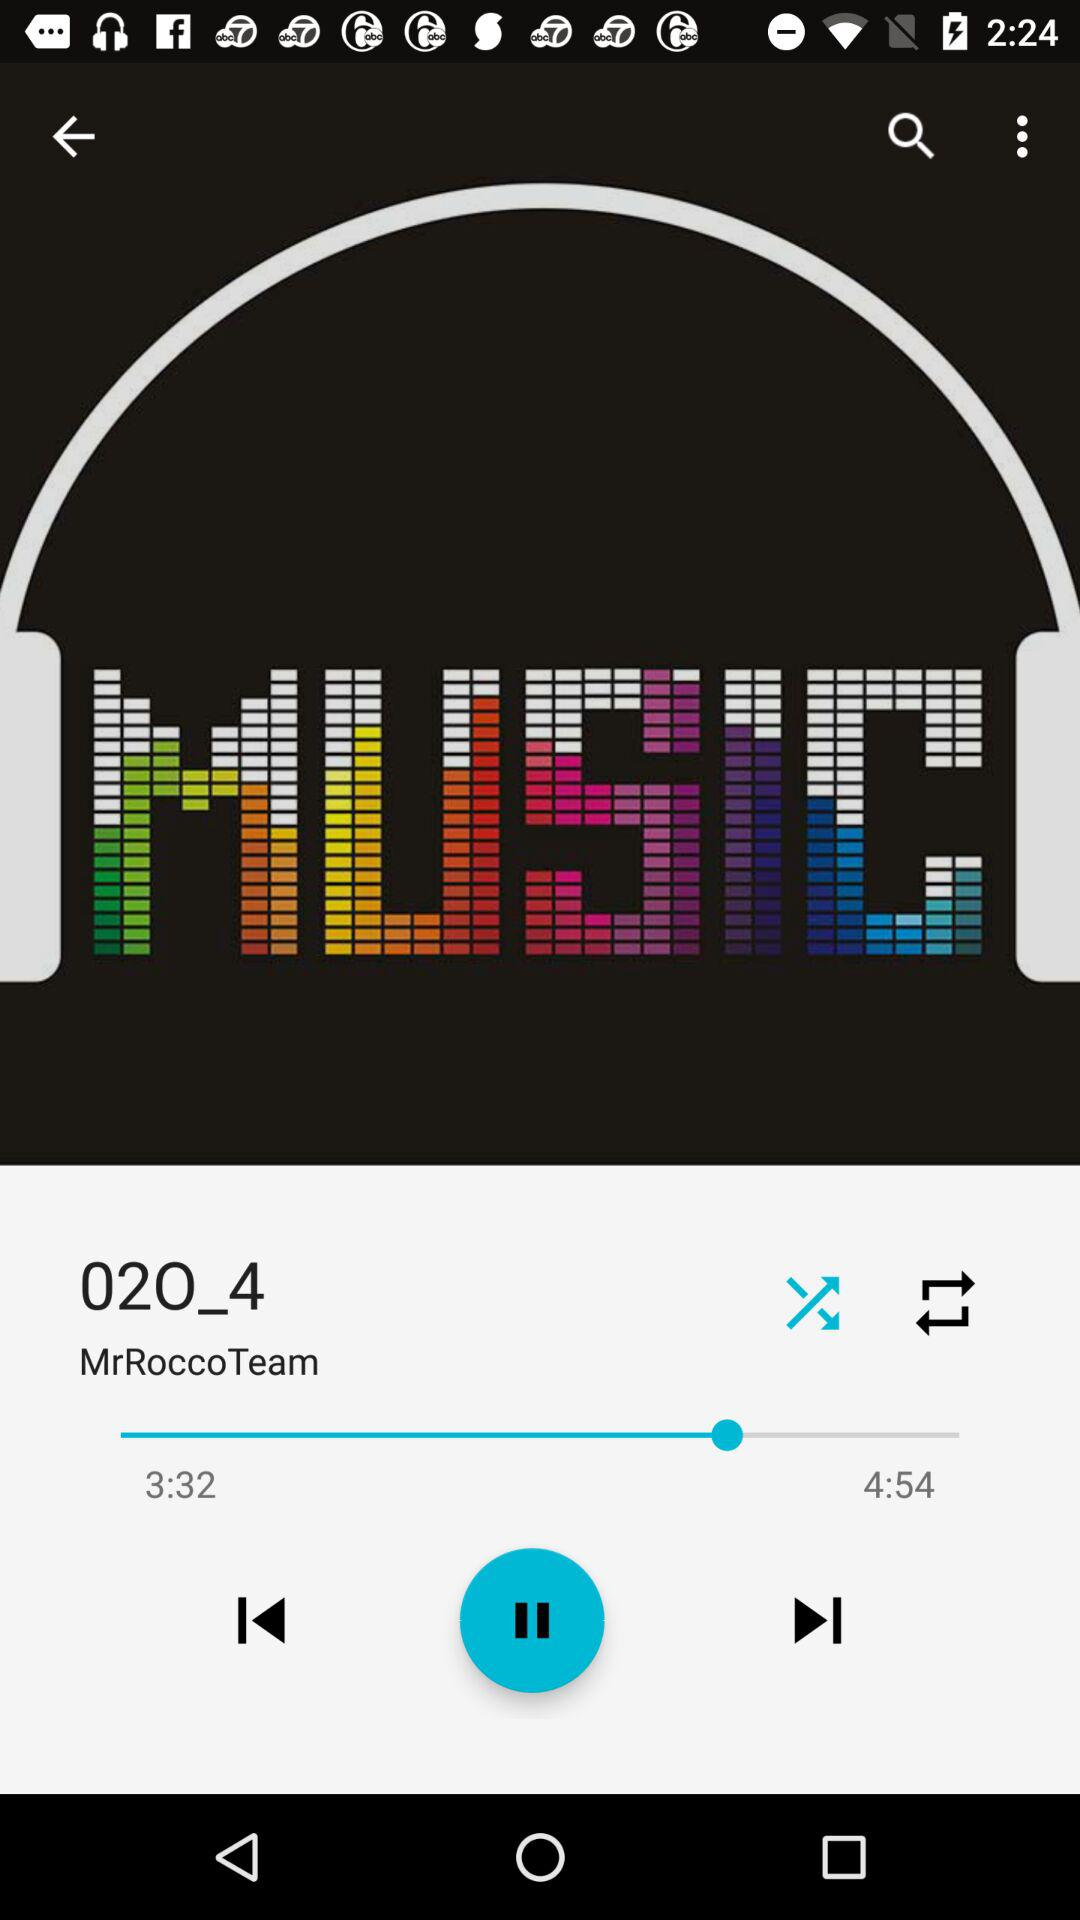What is the song name? The song name is "02O_4". 